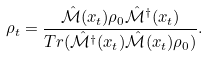<formula> <loc_0><loc_0><loc_500><loc_500>\rho _ { t } = \frac { \mathcal { \hat { M } } ( x _ { t } ) \rho _ { 0 } \mathcal { \hat { M } } ^ { \dagger } ( x _ { t } ) } { T r ( \mathcal { \hat { M } } ^ { \dagger } ( x _ { t } ) \mathcal { \hat { M } } ( x _ { t } ) \rho _ { 0 } ) } .</formula> 